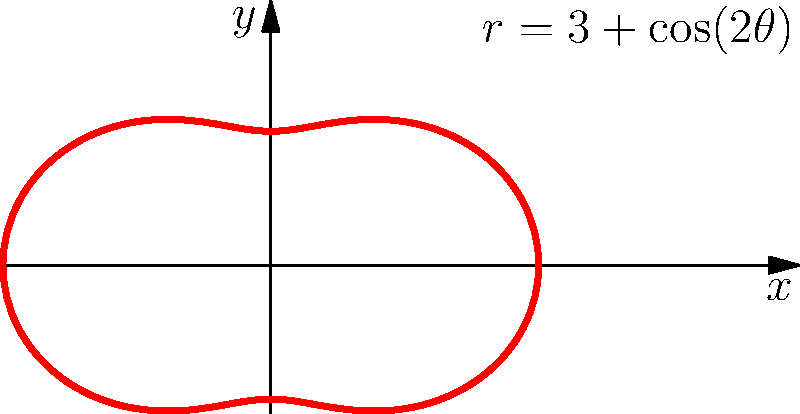In a futuristic energy shield design, the contour is mapped using the polar equation $r = 3 + \cos(2\theta)$. What is the maximum radius of this shield, and at which angle(s) does it occur? To find the maximum radius and the corresponding angle(s), we need to follow these steps:

1) The radius is given by the equation $r = 3 + \cos(2\theta)$.

2) The maximum radius will occur when $\cos(2\theta)$ is at its maximum value, which is 1.

3) When $\cos(2\theta) = 1$, the radius will be:
   $r_{max} = 3 + 1 = 4$

4) To find the angle(s) where this occurs, we need to solve:
   $\cos(2\theta) = 1$

5) This occurs when $2\theta = 0, 2\pi, 4\pi, ...$ or in general, $2\theta = 2\pi n$ where $n$ is any integer.

6) Solving for $\theta$:
   $\theta = 0, \pi, 2\pi, ...$  or  $\theta = \pi n$ where $n$ is any integer.

7) However, we typically consider angles in the range $[0, 2\pi)$, so the relevant angles are $0$ and $\pi$.

Therefore, the maximum radius is 4 units, occurring at angles 0 and $\pi$ radians (or equivalently, 0° and 180°).
Answer: Maximum radius: 4 units; Angles: 0 and $\pi$ radians 